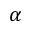Convert formula to latex. <formula><loc_0><loc_0><loc_500><loc_500>\alpha</formula> 